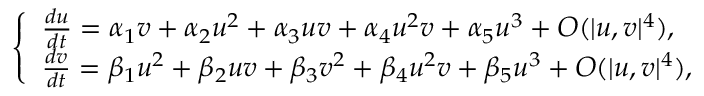Convert formula to latex. <formula><loc_0><loc_0><loc_500><loc_500>\left \{ \begin{array} { l l } { \frac { d u } { d t } = \alpha _ { 1 } v + \alpha _ { 2 } u ^ { 2 } + \alpha _ { 3 } u v + \alpha _ { 4 } u ^ { 2 } v + \alpha _ { 5 } u ^ { 3 } + O ( { | u , v | ^ { 4 } } ) , } \\ { \frac { d v } { d t } = \beta _ { 1 } u ^ { 2 } + \beta _ { 2 } u v + \beta _ { 3 } v ^ { 2 } + \beta _ { 4 } u ^ { 2 } v + \beta _ { 5 } u ^ { 3 } + O ( { | u , v | ^ { 4 } } ) , } \end{array}</formula> 